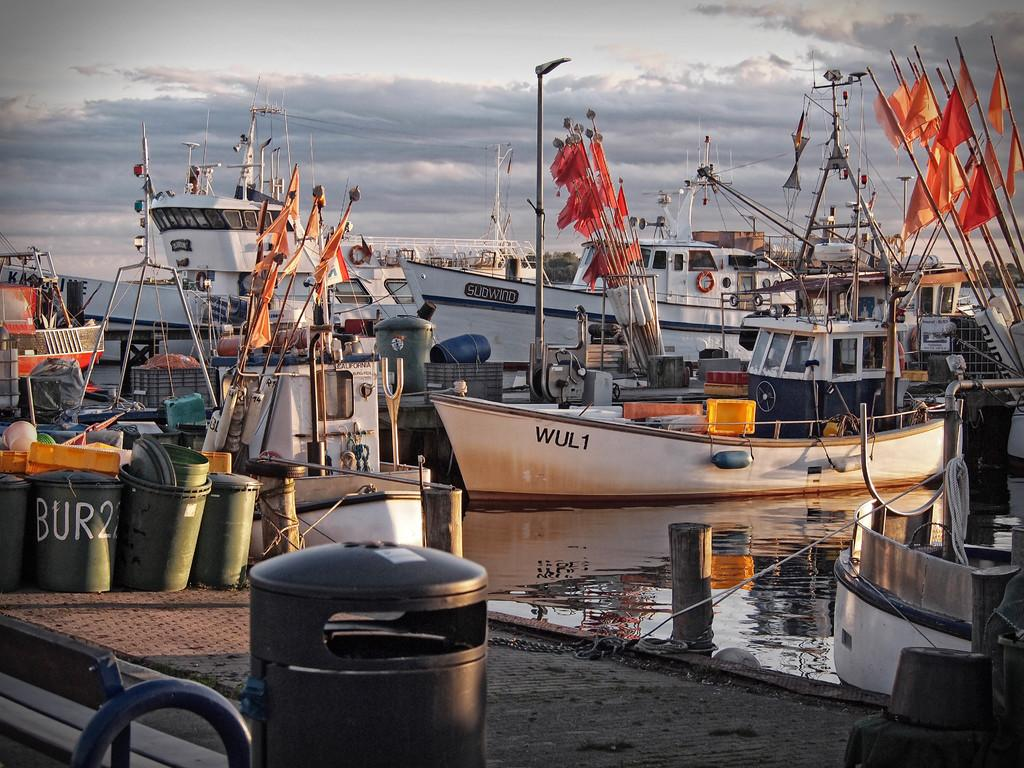<image>
Describe the image concisely. a trash can at a boat ramp says BUR22 